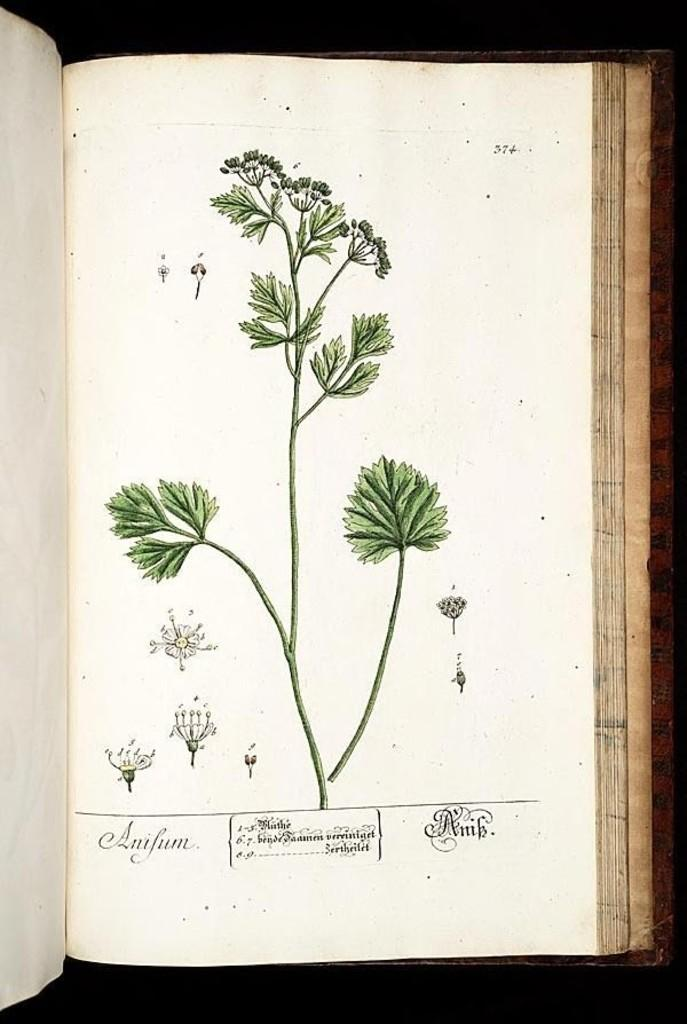What is the main object in the image? There is a book in the image. What type of images can be seen in the book? There is a picture of a plant and pictures of flowers in the image. What is written on the paper in the image? There is text on paper in the image. What color is the background at the bottom of the image? The bottom of the image has a black background. What type of stitch is used to sew the pages of the book in the image? There is no indication in the image that the pages of the book are sewn together, so it is not possible to determine the type of stitch used. 